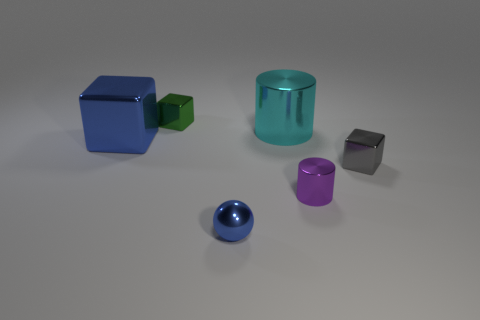Is the number of cyan metal objects greater than the number of blue things?
Your answer should be compact. No. Is the tiny blue ball made of the same material as the large cyan cylinder?
Offer a very short reply. Yes. What is the shape of the gray object that is the same material as the small blue ball?
Your answer should be very brief. Cube. Is the number of blue metallic balls less than the number of things?
Provide a short and direct response. Yes. What material is the tiny thing that is both in front of the cyan cylinder and to the left of the tiny cylinder?
Your answer should be compact. Metal. What is the size of the metallic block to the right of the small shiny cube that is behind the cyan metal object that is behind the big cube?
Give a very brief answer. Small. Do the green metal object and the blue metal thing behind the blue shiny ball have the same shape?
Give a very brief answer. Yes. How many metal things are both left of the cyan metallic object and in front of the big cyan metal object?
Keep it short and to the point. 2. How many green things are blocks or large rubber objects?
Offer a terse response. 1. There is a large metallic thing in front of the large cyan shiny thing; does it have the same color as the tiny object in front of the tiny purple object?
Offer a very short reply. Yes. 